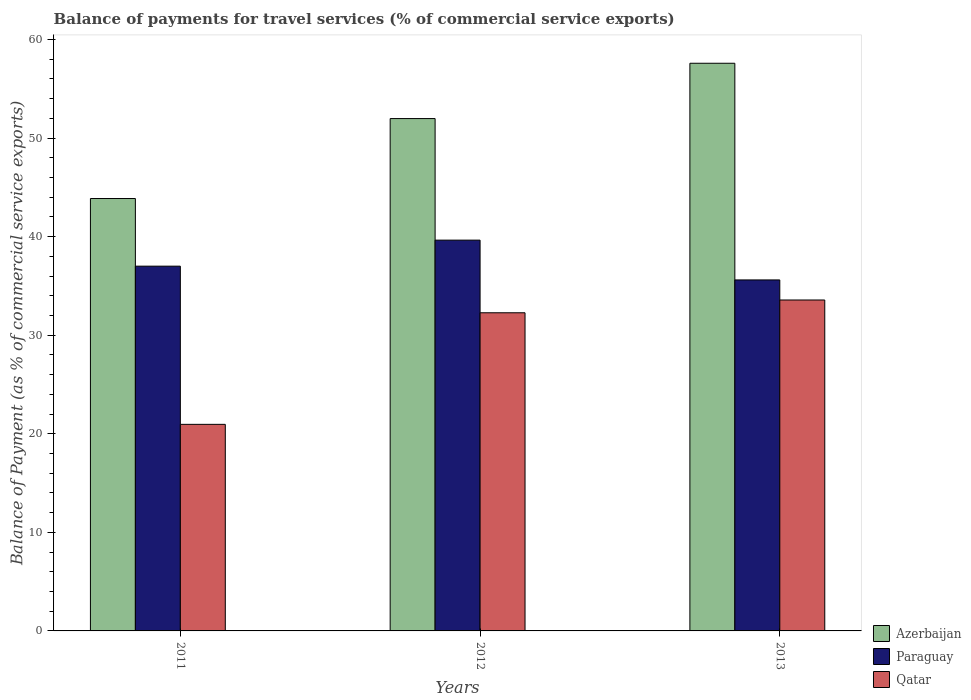How many groups of bars are there?
Ensure brevity in your answer.  3. What is the label of the 1st group of bars from the left?
Offer a terse response. 2011. What is the balance of payments for travel services in Qatar in 2012?
Your answer should be very brief. 32.28. Across all years, what is the maximum balance of payments for travel services in Qatar?
Your answer should be very brief. 33.57. Across all years, what is the minimum balance of payments for travel services in Qatar?
Your answer should be compact. 20.96. In which year was the balance of payments for travel services in Azerbaijan minimum?
Give a very brief answer. 2011. What is the total balance of payments for travel services in Azerbaijan in the graph?
Ensure brevity in your answer.  153.45. What is the difference between the balance of payments for travel services in Paraguay in 2012 and that in 2013?
Provide a succinct answer. 4.04. What is the difference between the balance of payments for travel services in Qatar in 2011 and the balance of payments for travel services in Paraguay in 2012?
Provide a short and direct response. -18.69. What is the average balance of payments for travel services in Paraguay per year?
Provide a succinct answer. 37.42. In the year 2013, what is the difference between the balance of payments for travel services in Qatar and balance of payments for travel services in Azerbaijan?
Ensure brevity in your answer.  -24.02. What is the ratio of the balance of payments for travel services in Qatar in 2011 to that in 2012?
Provide a short and direct response. 0.65. Is the difference between the balance of payments for travel services in Qatar in 2012 and 2013 greater than the difference between the balance of payments for travel services in Azerbaijan in 2012 and 2013?
Your response must be concise. Yes. What is the difference between the highest and the second highest balance of payments for travel services in Paraguay?
Keep it short and to the point. 2.64. What is the difference between the highest and the lowest balance of payments for travel services in Azerbaijan?
Make the answer very short. 13.72. What does the 2nd bar from the left in 2012 represents?
Your response must be concise. Paraguay. What does the 2nd bar from the right in 2012 represents?
Provide a short and direct response. Paraguay. How many bars are there?
Your response must be concise. 9. Does the graph contain grids?
Keep it short and to the point. No. Where does the legend appear in the graph?
Provide a short and direct response. Bottom right. What is the title of the graph?
Keep it short and to the point. Balance of payments for travel services (% of commercial service exports). Does "New Zealand" appear as one of the legend labels in the graph?
Your response must be concise. No. What is the label or title of the Y-axis?
Give a very brief answer. Balance of Payment (as % of commercial service exports). What is the Balance of Payment (as % of commercial service exports) in Azerbaijan in 2011?
Ensure brevity in your answer.  43.87. What is the Balance of Payment (as % of commercial service exports) in Paraguay in 2011?
Ensure brevity in your answer.  37.01. What is the Balance of Payment (as % of commercial service exports) of Qatar in 2011?
Ensure brevity in your answer.  20.96. What is the Balance of Payment (as % of commercial service exports) of Azerbaijan in 2012?
Make the answer very short. 51.98. What is the Balance of Payment (as % of commercial service exports) of Paraguay in 2012?
Offer a very short reply. 39.65. What is the Balance of Payment (as % of commercial service exports) in Qatar in 2012?
Your answer should be very brief. 32.28. What is the Balance of Payment (as % of commercial service exports) of Azerbaijan in 2013?
Make the answer very short. 57.59. What is the Balance of Payment (as % of commercial service exports) of Paraguay in 2013?
Provide a succinct answer. 35.61. What is the Balance of Payment (as % of commercial service exports) of Qatar in 2013?
Offer a very short reply. 33.57. Across all years, what is the maximum Balance of Payment (as % of commercial service exports) of Azerbaijan?
Offer a terse response. 57.59. Across all years, what is the maximum Balance of Payment (as % of commercial service exports) of Paraguay?
Keep it short and to the point. 39.65. Across all years, what is the maximum Balance of Payment (as % of commercial service exports) of Qatar?
Your response must be concise. 33.57. Across all years, what is the minimum Balance of Payment (as % of commercial service exports) in Azerbaijan?
Make the answer very short. 43.87. Across all years, what is the minimum Balance of Payment (as % of commercial service exports) in Paraguay?
Make the answer very short. 35.61. Across all years, what is the minimum Balance of Payment (as % of commercial service exports) of Qatar?
Your response must be concise. 20.96. What is the total Balance of Payment (as % of commercial service exports) in Azerbaijan in the graph?
Offer a terse response. 153.45. What is the total Balance of Payment (as % of commercial service exports) in Paraguay in the graph?
Ensure brevity in your answer.  112.27. What is the total Balance of Payment (as % of commercial service exports) in Qatar in the graph?
Give a very brief answer. 86.81. What is the difference between the Balance of Payment (as % of commercial service exports) in Azerbaijan in 2011 and that in 2012?
Keep it short and to the point. -8.11. What is the difference between the Balance of Payment (as % of commercial service exports) of Paraguay in 2011 and that in 2012?
Provide a short and direct response. -2.64. What is the difference between the Balance of Payment (as % of commercial service exports) of Qatar in 2011 and that in 2012?
Offer a terse response. -11.32. What is the difference between the Balance of Payment (as % of commercial service exports) in Azerbaijan in 2011 and that in 2013?
Your answer should be very brief. -13.72. What is the difference between the Balance of Payment (as % of commercial service exports) in Paraguay in 2011 and that in 2013?
Offer a terse response. 1.4. What is the difference between the Balance of Payment (as % of commercial service exports) of Qatar in 2011 and that in 2013?
Your response must be concise. -12.62. What is the difference between the Balance of Payment (as % of commercial service exports) of Azerbaijan in 2012 and that in 2013?
Give a very brief answer. -5.61. What is the difference between the Balance of Payment (as % of commercial service exports) of Paraguay in 2012 and that in 2013?
Make the answer very short. 4.04. What is the difference between the Balance of Payment (as % of commercial service exports) of Qatar in 2012 and that in 2013?
Offer a terse response. -1.3. What is the difference between the Balance of Payment (as % of commercial service exports) in Azerbaijan in 2011 and the Balance of Payment (as % of commercial service exports) in Paraguay in 2012?
Keep it short and to the point. 4.22. What is the difference between the Balance of Payment (as % of commercial service exports) of Azerbaijan in 2011 and the Balance of Payment (as % of commercial service exports) of Qatar in 2012?
Make the answer very short. 11.59. What is the difference between the Balance of Payment (as % of commercial service exports) of Paraguay in 2011 and the Balance of Payment (as % of commercial service exports) of Qatar in 2012?
Make the answer very short. 4.73. What is the difference between the Balance of Payment (as % of commercial service exports) of Azerbaijan in 2011 and the Balance of Payment (as % of commercial service exports) of Paraguay in 2013?
Offer a terse response. 8.26. What is the difference between the Balance of Payment (as % of commercial service exports) in Azerbaijan in 2011 and the Balance of Payment (as % of commercial service exports) in Qatar in 2013?
Your response must be concise. 10.3. What is the difference between the Balance of Payment (as % of commercial service exports) of Paraguay in 2011 and the Balance of Payment (as % of commercial service exports) of Qatar in 2013?
Your response must be concise. 3.43. What is the difference between the Balance of Payment (as % of commercial service exports) in Azerbaijan in 2012 and the Balance of Payment (as % of commercial service exports) in Paraguay in 2013?
Offer a very short reply. 16.37. What is the difference between the Balance of Payment (as % of commercial service exports) of Azerbaijan in 2012 and the Balance of Payment (as % of commercial service exports) of Qatar in 2013?
Give a very brief answer. 18.41. What is the difference between the Balance of Payment (as % of commercial service exports) in Paraguay in 2012 and the Balance of Payment (as % of commercial service exports) in Qatar in 2013?
Give a very brief answer. 6.07. What is the average Balance of Payment (as % of commercial service exports) of Azerbaijan per year?
Provide a short and direct response. 51.15. What is the average Balance of Payment (as % of commercial service exports) of Paraguay per year?
Your answer should be very brief. 37.42. What is the average Balance of Payment (as % of commercial service exports) in Qatar per year?
Keep it short and to the point. 28.94. In the year 2011, what is the difference between the Balance of Payment (as % of commercial service exports) in Azerbaijan and Balance of Payment (as % of commercial service exports) in Paraguay?
Offer a very short reply. 6.86. In the year 2011, what is the difference between the Balance of Payment (as % of commercial service exports) of Azerbaijan and Balance of Payment (as % of commercial service exports) of Qatar?
Offer a very short reply. 22.91. In the year 2011, what is the difference between the Balance of Payment (as % of commercial service exports) of Paraguay and Balance of Payment (as % of commercial service exports) of Qatar?
Keep it short and to the point. 16.05. In the year 2012, what is the difference between the Balance of Payment (as % of commercial service exports) of Azerbaijan and Balance of Payment (as % of commercial service exports) of Paraguay?
Make the answer very short. 12.33. In the year 2012, what is the difference between the Balance of Payment (as % of commercial service exports) of Azerbaijan and Balance of Payment (as % of commercial service exports) of Qatar?
Your answer should be compact. 19.7. In the year 2012, what is the difference between the Balance of Payment (as % of commercial service exports) in Paraguay and Balance of Payment (as % of commercial service exports) in Qatar?
Ensure brevity in your answer.  7.37. In the year 2013, what is the difference between the Balance of Payment (as % of commercial service exports) in Azerbaijan and Balance of Payment (as % of commercial service exports) in Paraguay?
Provide a succinct answer. 21.98. In the year 2013, what is the difference between the Balance of Payment (as % of commercial service exports) of Azerbaijan and Balance of Payment (as % of commercial service exports) of Qatar?
Your response must be concise. 24.02. In the year 2013, what is the difference between the Balance of Payment (as % of commercial service exports) of Paraguay and Balance of Payment (as % of commercial service exports) of Qatar?
Ensure brevity in your answer.  2.04. What is the ratio of the Balance of Payment (as % of commercial service exports) of Azerbaijan in 2011 to that in 2012?
Your answer should be very brief. 0.84. What is the ratio of the Balance of Payment (as % of commercial service exports) in Paraguay in 2011 to that in 2012?
Make the answer very short. 0.93. What is the ratio of the Balance of Payment (as % of commercial service exports) of Qatar in 2011 to that in 2012?
Give a very brief answer. 0.65. What is the ratio of the Balance of Payment (as % of commercial service exports) of Azerbaijan in 2011 to that in 2013?
Offer a very short reply. 0.76. What is the ratio of the Balance of Payment (as % of commercial service exports) of Paraguay in 2011 to that in 2013?
Offer a very short reply. 1.04. What is the ratio of the Balance of Payment (as % of commercial service exports) of Qatar in 2011 to that in 2013?
Provide a succinct answer. 0.62. What is the ratio of the Balance of Payment (as % of commercial service exports) in Azerbaijan in 2012 to that in 2013?
Ensure brevity in your answer.  0.9. What is the ratio of the Balance of Payment (as % of commercial service exports) in Paraguay in 2012 to that in 2013?
Provide a succinct answer. 1.11. What is the ratio of the Balance of Payment (as % of commercial service exports) of Qatar in 2012 to that in 2013?
Provide a short and direct response. 0.96. What is the difference between the highest and the second highest Balance of Payment (as % of commercial service exports) in Azerbaijan?
Give a very brief answer. 5.61. What is the difference between the highest and the second highest Balance of Payment (as % of commercial service exports) in Paraguay?
Provide a short and direct response. 2.64. What is the difference between the highest and the second highest Balance of Payment (as % of commercial service exports) of Qatar?
Your response must be concise. 1.3. What is the difference between the highest and the lowest Balance of Payment (as % of commercial service exports) of Azerbaijan?
Your answer should be very brief. 13.72. What is the difference between the highest and the lowest Balance of Payment (as % of commercial service exports) of Paraguay?
Keep it short and to the point. 4.04. What is the difference between the highest and the lowest Balance of Payment (as % of commercial service exports) in Qatar?
Keep it short and to the point. 12.62. 